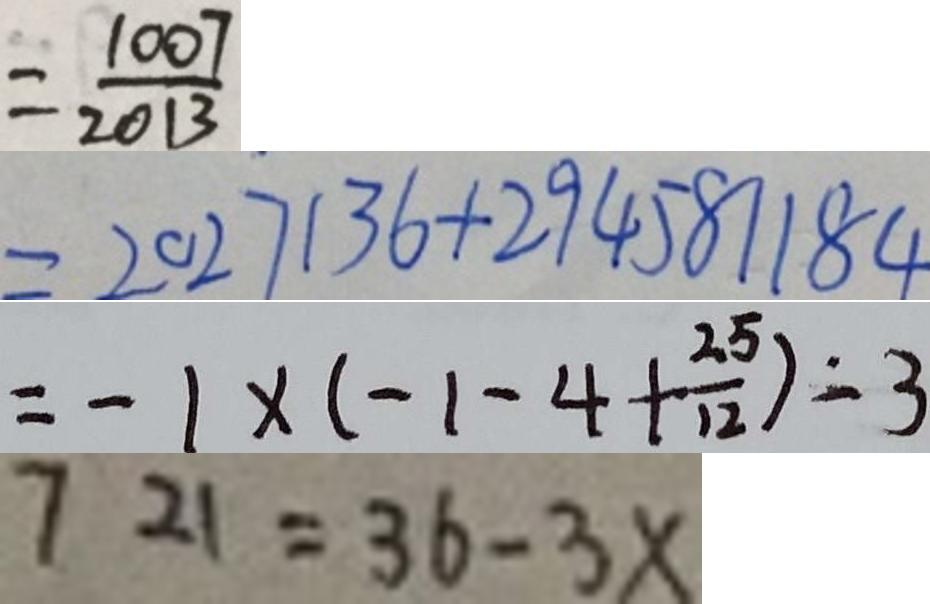<formula> <loc_0><loc_0><loc_500><loc_500>= \frac { 1 0 0 7 } { 2 0 1 3 } 
 = 2 0 2 7 1 3 6 + 2 9 4 5 8 1 1 8 4 
 = - 1 \times ( - 1 - 4 + \frac { 2 5 } { 1 2 } ) = 3 
 7 2 1 = 3 6 - 3 x</formula> 